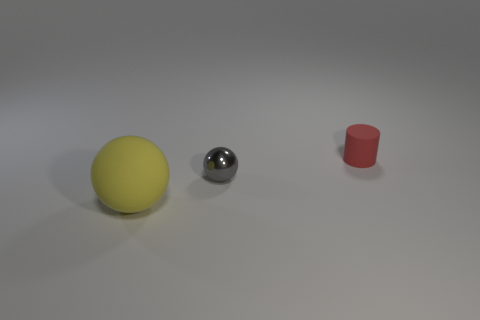Is there anything else that has the same size as the matte sphere?
Provide a short and direct response. No. Are there any other things that are made of the same material as the tiny gray thing?
Provide a succinct answer. No. Is there a large blue thing made of the same material as the tiny red cylinder?
Provide a succinct answer. No. What is the small object on the left side of the red thing made of?
Ensure brevity in your answer.  Metal. What material is the large yellow sphere?
Make the answer very short. Rubber. Is the object that is to the right of the metallic ball made of the same material as the large yellow thing?
Offer a very short reply. Yes. Is the number of gray shiny balls that are in front of the big matte sphere less than the number of big balls?
Your answer should be very brief. Yes. What is the color of the shiny object that is the same size as the red cylinder?
Provide a succinct answer. Gray. How many other big yellow matte objects have the same shape as the yellow thing?
Your answer should be very brief. 0. What color is the rubber object that is behind the small metallic sphere?
Offer a very short reply. Red. 